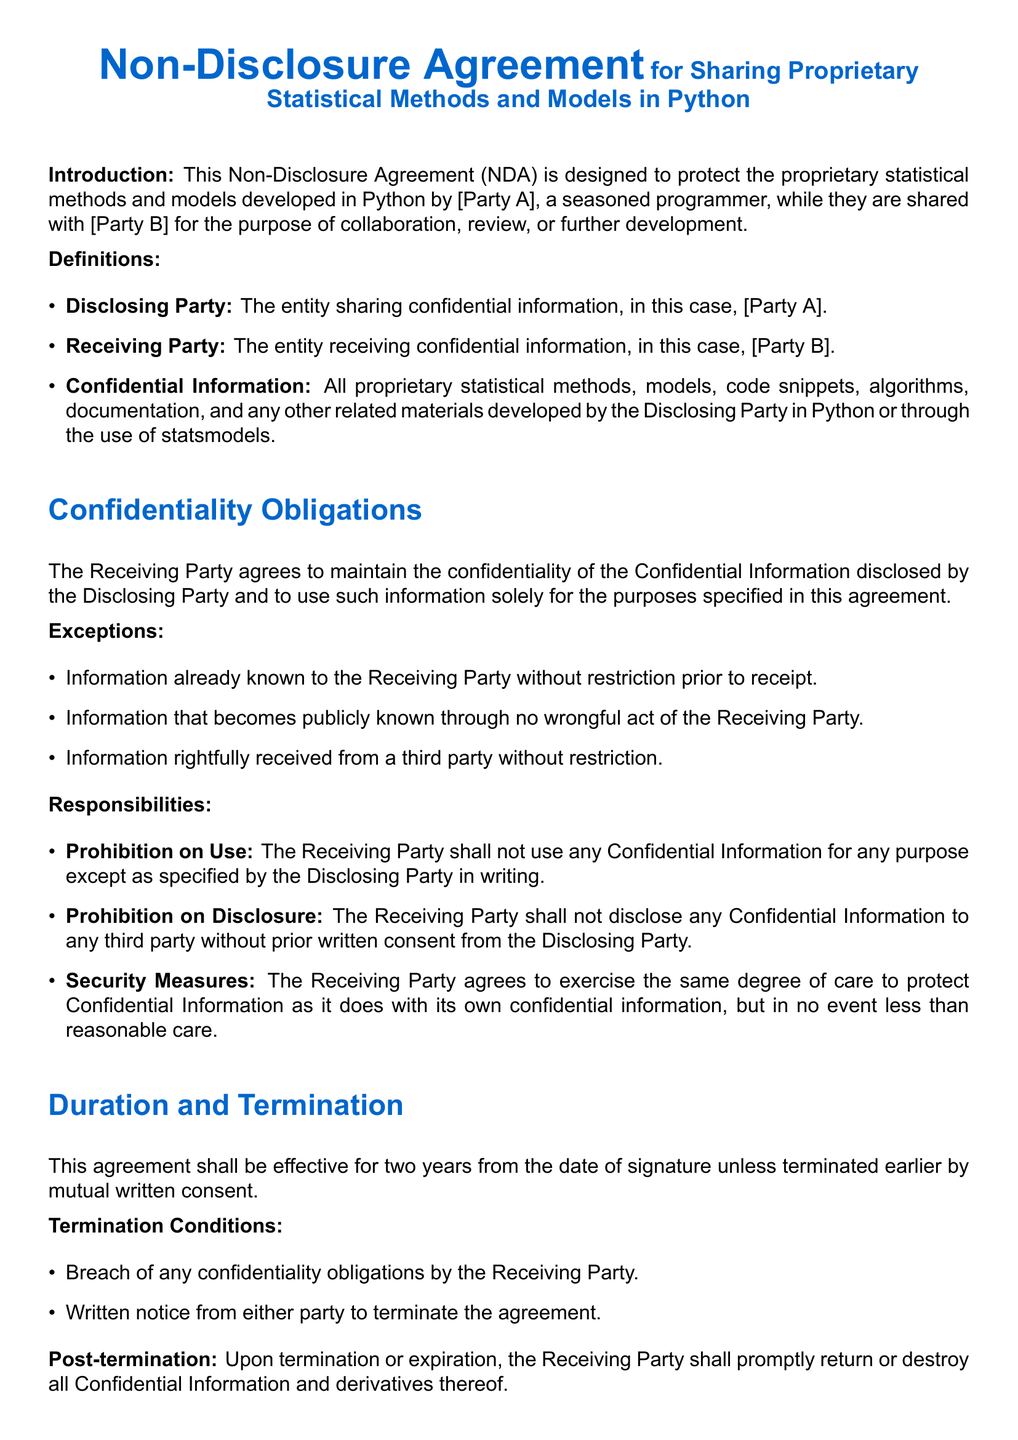what is the title of the document? The document is titled "Non-Disclosure Agreement for Sharing Proprietary Statistical Methods and Models in Python."
Answer: Non-Disclosure Agreement for Sharing Proprietary Statistical Methods and Models in Python who are the parties involved in this agreement? The parties involved are [Party A] as the Disclosing Party and [Party B] as the Receiving Party.
Answer: [Party A], [Party B] how long is the agreement effective? The document states that the agreement shall be effective for two years from the date of signature.
Answer: two years what is the governing law for the agreement? The agreement is governed by the laws of the jurisdiction in which the Disclosing Party resides.
Answer: jurisdiction in which the Disclosing Party resides what must the Receiving Party do with Confidential Information upon termination? Upon termination, the Receiving Party must promptly return or destroy all Confidential Information and derivatives thereof.
Answer: return or destroy what is one of the exceptions to confidentiality obligations? One exception is information rightfully received from a third party without restriction.
Answer: information rightfully received from a third party without restriction what type of resolution does the agreement specify for disputes? The agreement specifies that disputes shall be resolved through binding arbitration.
Answer: binding arbitration what is one responsibility of the Receiving Party regarding Confidential Information? The Receiving Party must not disclose any Confidential Information to any third party without prior written consent.
Answer: not disclose to any third party without prior written consent 